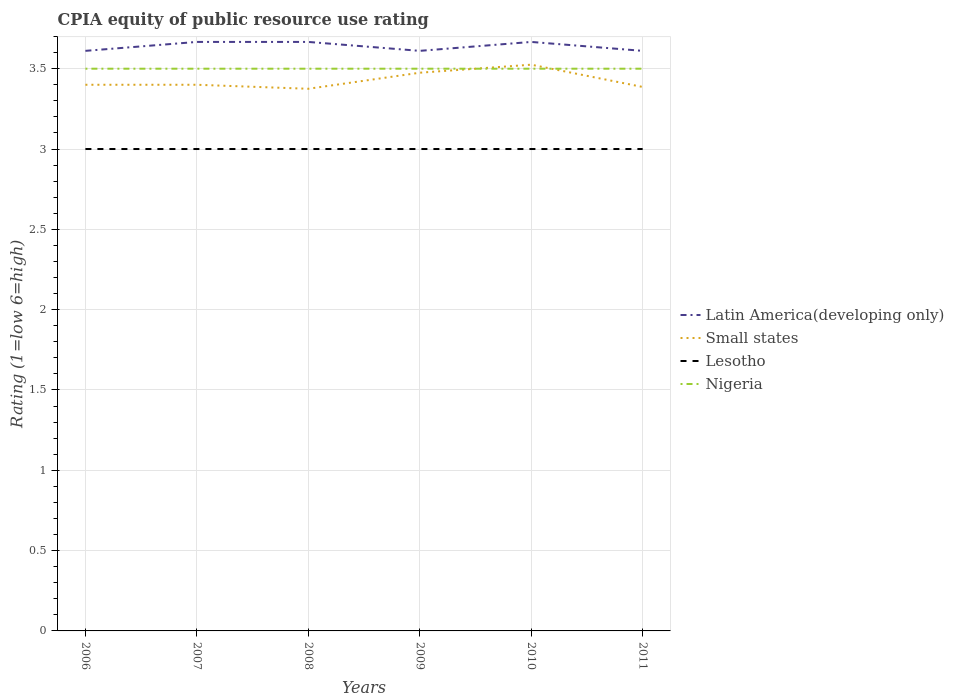Across all years, what is the maximum CPIA rating in Small states?
Provide a short and direct response. 3.38. What is the total CPIA rating in Small states in the graph?
Keep it short and to the point. 0.01. What is the difference between the highest and the second highest CPIA rating in Latin America(developing only)?
Make the answer very short. 0.06. Is the CPIA rating in Nigeria strictly greater than the CPIA rating in Lesotho over the years?
Ensure brevity in your answer.  No. Are the values on the major ticks of Y-axis written in scientific E-notation?
Offer a terse response. No. Does the graph contain grids?
Give a very brief answer. Yes. Where does the legend appear in the graph?
Keep it short and to the point. Center right. How are the legend labels stacked?
Your answer should be compact. Vertical. What is the title of the graph?
Give a very brief answer. CPIA equity of public resource use rating. Does "Jamaica" appear as one of the legend labels in the graph?
Offer a very short reply. No. What is the Rating (1=low 6=high) of Latin America(developing only) in 2006?
Make the answer very short. 3.61. What is the Rating (1=low 6=high) of Small states in 2006?
Ensure brevity in your answer.  3.4. What is the Rating (1=low 6=high) of Nigeria in 2006?
Your response must be concise. 3.5. What is the Rating (1=low 6=high) in Latin America(developing only) in 2007?
Your response must be concise. 3.67. What is the Rating (1=low 6=high) of Small states in 2007?
Ensure brevity in your answer.  3.4. What is the Rating (1=low 6=high) of Latin America(developing only) in 2008?
Provide a short and direct response. 3.67. What is the Rating (1=low 6=high) of Small states in 2008?
Provide a short and direct response. 3.38. What is the Rating (1=low 6=high) in Lesotho in 2008?
Keep it short and to the point. 3. What is the Rating (1=low 6=high) of Nigeria in 2008?
Provide a short and direct response. 3.5. What is the Rating (1=low 6=high) in Latin America(developing only) in 2009?
Offer a terse response. 3.61. What is the Rating (1=low 6=high) in Small states in 2009?
Provide a succinct answer. 3.48. What is the Rating (1=low 6=high) in Latin America(developing only) in 2010?
Ensure brevity in your answer.  3.67. What is the Rating (1=low 6=high) of Small states in 2010?
Ensure brevity in your answer.  3.52. What is the Rating (1=low 6=high) of Lesotho in 2010?
Provide a succinct answer. 3. What is the Rating (1=low 6=high) of Latin America(developing only) in 2011?
Give a very brief answer. 3.61. What is the Rating (1=low 6=high) in Small states in 2011?
Provide a short and direct response. 3.39. What is the Rating (1=low 6=high) in Lesotho in 2011?
Ensure brevity in your answer.  3. Across all years, what is the maximum Rating (1=low 6=high) of Latin America(developing only)?
Give a very brief answer. 3.67. Across all years, what is the maximum Rating (1=low 6=high) of Small states?
Provide a short and direct response. 3.52. Across all years, what is the maximum Rating (1=low 6=high) in Lesotho?
Make the answer very short. 3. Across all years, what is the minimum Rating (1=low 6=high) in Latin America(developing only)?
Ensure brevity in your answer.  3.61. Across all years, what is the minimum Rating (1=low 6=high) of Small states?
Your answer should be compact. 3.38. Across all years, what is the minimum Rating (1=low 6=high) of Nigeria?
Your answer should be compact. 3.5. What is the total Rating (1=low 6=high) of Latin America(developing only) in the graph?
Provide a short and direct response. 21.83. What is the total Rating (1=low 6=high) of Small states in the graph?
Ensure brevity in your answer.  20.56. What is the total Rating (1=low 6=high) of Lesotho in the graph?
Offer a terse response. 18. What is the difference between the Rating (1=low 6=high) in Latin America(developing only) in 2006 and that in 2007?
Make the answer very short. -0.06. What is the difference between the Rating (1=low 6=high) in Small states in 2006 and that in 2007?
Your answer should be compact. 0. What is the difference between the Rating (1=low 6=high) of Lesotho in 2006 and that in 2007?
Your answer should be very brief. 0. What is the difference between the Rating (1=low 6=high) of Latin America(developing only) in 2006 and that in 2008?
Offer a very short reply. -0.06. What is the difference between the Rating (1=low 6=high) of Small states in 2006 and that in 2008?
Offer a very short reply. 0.03. What is the difference between the Rating (1=low 6=high) in Latin America(developing only) in 2006 and that in 2009?
Offer a very short reply. 0. What is the difference between the Rating (1=low 6=high) in Small states in 2006 and that in 2009?
Ensure brevity in your answer.  -0.07. What is the difference between the Rating (1=low 6=high) in Nigeria in 2006 and that in 2009?
Your answer should be very brief. 0. What is the difference between the Rating (1=low 6=high) of Latin America(developing only) in 2006 and that in 2010?
Your response must be concise. -0.06. What is the difference between the Rating (1=low 6=high) in Small states in 2006 and that in 2010?
Your answer should be very brief. -0.12. What is the difference between the Rating (1=low 6=high) in Lesotho in 2006 and that in 2010?
Keep it short and to the point. 0. What is the difference between the Rating (1=low 6=high) in Nigeria in 2006 and that in 2010?
Your answer should be compact. 0. What is the difference between the Rating (1=low 6=high) of Small states in 2006 and that in 2011?
Keep it short and to the point. 0.01. What is the difference between the Rating (1=low 6=high) in Lesotho in 2006 and that in 2011?
Your answer should be compact. 0. What is the difference between the Rating (1=low 6=high) of Nigeria in 2006 and that in 2011?
Provide a succinct answer. 0. What is the difference between the Rating (1=low 6=high) of Small states in 2007 and that in 2008?
Offer a very short reply. 0.03. What is the difference between the Rating (1=low 6=high) in Latin America(developing only) in 2007 and that in 2009?
Make the answer very short. 0.06. What is the difference between the Rating (1=low 6=high) of Small states in 2007 and that in 2009?
Offer a very short reply. -0.07. What is the difference between the Rating (1=low 6=high) of Small states in 2007 and that in 2010?
Make the answer very short. -0.12. What is the difference between the Rating (1=low 6=high) of Nigeria in 2007 and that in 2010?
Provide a succinct answer. 0. What is the difference between the Rating (1=low 6=high) in Latin America(developing only) in 2007 and that in 2011?
Make the answer very short. 0.06. What is the difference between the Rating (1=low 6=high) of Small states in 2007 and that in 2011?
Your response must be concise. 0.01. What is the difference between the Rating (1=low 6=high) in Lesotho in 2007 and that in 2011?
Ensure brevity in your answer.  0. What is the difference between the Rating (1=low 6=high) of Latin America(developing only) in 2008 and that in 2009?
Make the answer very short. 0.06. What is the difference between the Rating (1=low 6=high) in Lesotho in 2008 and that in 2009?
Your answer should be compact. 0. What is the difference between the Rating (1=low 6=high) of Latin America(developing only) in 2008 and that in 2010?
Ensure brevity in your answer.  0. What is the difference between the Rating (1=low 6=high) of Small states in 2008 and that in 2010?
Ensure brevity in your answer.  -0.15. What is the difference between the Rating (1=low 6=high) in Nigeria in 2008 and that in 2010?
Give a very brief answer. 0. What is the difference between the Rating (1=low 6=high) of Latin America(developing only) in 2008 and that in 2011?
Keep it short and to the point. 0.06. What is the difference between the Rating (1=low 6=high) in Small states in 2008 and that in 2011?
Make the answer very short. -0.01. What is the difference between the Rating (1=low 6=high) of Latin America(developing only) in 2009 and that in 2010?
Your response must be concise. -0.06. What is the difference between the Rating (1=low 6=high) of Small states in 2009 and that in 2010?
Offer a terse response. -0.05. What is the difference between the Rating (1=low 6=high) of Lesotho in 2009 and that in 2010?
Give a very brief answer. 0. What is the difference between the Rating (1=low 6=high) of Latin America(developing only) in 2009 and that in 2011?
Make the answer very short. 0. What is the difference between the Rating (1=low 6=high) of Small states in 2009 and that in 2011?
Your answer should be very brief. 0.09. What is the difference between the Rating (1=low 6=high) in Nigeria in 2009 and that in 2011?
Offer a very short reply. 0. What is the difference between the Rating (1=low 6=high) in Latin America(developing only) in 2010 and that in 2011?
Provide a short and direct response. 0.06. What is the difference between the Rating (1=low 6=high) in Small states in 2010 and that in 2011?
Your answer should be compact. 0.14. What is the difference between the Rating (1=low 6=high) of Latin America(developing only) in 2006 and the Rating (1=low 6=high) of Small states in 2007?
Your answer should be very brief. 0.21. What is the difference between the Rating (1=low 6=high) in Latin America(developing only) in 2006 and the Rating (1=low 6=high) in Lesotho in 2007?
Keep it short and to the point. 0.61. What is the difference between the Rating (1=low 6=high) in Latin America(developing only) in 2006 and the Rating (1=low 6=high) in Nigeria in 2007?
Make the answer very short. 0.11. What is the difference between the Rating (1=low 6=high) of Small states in 2006 and the Rating (1=low 6=high) of Lesotho in 2007?
Offer a terse response. 0.4. What is the difference between the Rating (1=low 6=high) of Small states in 2006 and the Rating (1=low 6=high) of Nigeria in 2007?
Your answer should be compact. -0.1. What is the difference between the Rating (1=low 6=high) of Latin America(developing only) in 2006 and the Rating (1=low 6=high) of Small states in 2008?
Your answer should be compact. 0.24. What is the difference between the Rating (1=low 6=high) in Latin America(developing only) in 2006 and the Rating (1=low 6=high) in Lesotho in 2008?
Ensure brevity in your answer.  0.61. What is the difference between the Rating (1=low 6=high) of Small states in 2006 and the Rating (1=low 6=high) of Nigeria in 2008?
Ensure brevity in your answer.  -0.1. What is the difference between the Rating (1=low 6=high) of Lesotho in 2006 and the Rating (1=low 6=high) of Nigeria in 2008?
Ensure brevity in your answer.  -0.5. What is the difference between the Rating (1=low 6=high) of Latin America(developing only) in 2006 and the Rating (1=low 6=high) of Small states in 2009?
Your response must be concise. 0.14. What is the difference between the Rating (1=low 6=high) of Latin America(developing only) in 2006 and the Rating (1=low 6=high) of Lesotho in 2009?
Make the answer very short. 0.61. What is the difference between the Rating (1=low 6=high) in Latin America(developing only) in 2006 and the Rating (1=low 6=high) in Nigeria in 2009?
Give a very brief answer. 0.11. What is the difference between the Rating (1=low 6=high) in Small states in 2006 and the Rating (1=low 6=high) in Lesotho in 2009?
Give a very brief answer. 0.4. What is the difference between the Rating (1=low 6=high) of Small states in 2006 and the Rating (1=low 6=high) of Nigeria in 2009?
Give a very brief answer. -0.1. What is the difference between the Rating (1=low 6=high) in Lesotho in 2006 and the Rating (1=low 6=high) in Nigeria in 2009?
Your answer should be compact. -0.5. What is the difference between the Rating (1=low 6=high) of Latin America(developing only) in 2006 and the Rating (1=low 6=high) of Small states in 2010?
Your answer should be compact. 0.09. What is the difference between the Rating (1=low 6=high) of Latin America(developing only) in 2006 and the Rating (1=low 6=high) of Lesotho in 2010?
Your answer should be very brief. 0.61. What is the difference between the Rating (1=low 6=high) in Small states in 2006 and the Rating (1=low 6=high) in Nigeria in 2010?
Offer a terse response. -0.1. What is the difference between the Rating (1=low 6=high) of Latin America(developing only) in 2006 and the Rating (1=low 6=high) of Small states in 2011?
Offer a terse response. 0.22. What is the difference between the Rating (1=low 6=high) of Latin America(developing only) in 2006 and the Rating (1=low 6=high) of Lesotho in 2011?
Ensure brevity in your answer.  0.61. What is the difference between the Rating (1=low 6=high) in Small states in 2006 and the Rating (1=low 6=high) in Lesotho in 2011?
Offer a very short reply. 0.4. What is the difference between the Rating (1=low 6=high) of Small states in 2006 and the Rating (1=low 6=high) of Nigeria in 2011?
Ensure brevity in your answer.  -0.1. What is the difference between the Rating (1=low 6=high) in Lesotho in 2006 and the Rating (1=low 6=high) in Nigeria in 2011?
Give a very brief answer. -0.5. What is the difference between the Rating (1=low 6=high) of Latin America(developing only) in 2007 and the Rating (1=low 6=high) of Small states in 2008?
Offer a terse response. 0.29. What is the difference between the Rating (1=low 6=high) of Latin America(developing only) in 2007 and the Rating (1=low 6=high) of Lesotho in 2008?
Give a very brief answer. 0.67. What is the difference between the Rating (1=low 6=high) in Small states in 2007 and the Rating (1=low 6=high) in Lesotho in 2008?
Provide a short and direct response. 0.4. What is the difference between the Rating (1=low 6=high) in Latin America(developing only) in 2007 and the Rating (1=low 6=high) in Small states in 2009?
Provide a succinct answer. 0.19. What is the difference between the Rating (1=low 6=high) of Latin America(developing only) in 2007 and the Rating (1=low 6=high) of Lesotho in 2009?
Keep it short and to the point. 0.67. What is the difference between the Rating (1=low 6=high) in Latin America(developing only) in 2007 and the Rating (1=low 6=high) in Nigeria in 2009?
Ensure brevity in your answer.  0.17. What is the difference between the Rating (1=low 6=high) of Small states in 2007 and the Rating (1=low 6=high) of Lesotho in 2009?
Give a very brief answer. 0.4. What is the difference between the Rating (1=low 6=high) in Small states in 2007 and the Rating (1=low 6=high) in Nigeria in 2009?
Ensure brevity in your answer.  -0.1. What is the difference between the Rating (1=low 6=high) of Lesotho in 2007 and the Rating (1=low 6=high) of Nigeria in 2009?
Keep it short and to the point. -0.5. What is the difference between the Rating (1=low 6=high) in Latin America(developing only) in 2007 and the Rating (1=low 6=high) in Small states in 2010?
Your response must be concise. 0.14. What is the difference between the Rating (1=low 6=high) of Latin America(developing only) in 2007 and the Rating (1=low 6=high) of Lesotho in 2010?
Ensure brevity in your answer.  0.67. What is the difference between the Rating (1=low 6=high) of Latin America(developing only) in 2007 and the Rating (1=low 6=high) of Nigeria in 2010?
Your answer should be very brief. 0.17. What is the difference between the Rating (1=low 6=high) of Small states in 2007 and the Rating (1=low 6=high) of Nigeria in 2010?
Give a very brief answer. -0.1. What is the difference between the Rating (1=low 6=high) in Latin America(developing only) in 2007 and the Rating (1=low 6=high) in Small states in 2011?
Give a very brief answer. 0.28. What is the difference between the Rating (1=low 6=high) in Latin America(developing only) in 2007 and the Rating (1=low 6=high) in Nigeria in 2011?
Offer a terse response. 0.17. What is the difference between the Rating (1=low 6=high) in Lesotho in 2007 and the Rating (1=low 6=high) in Nigeria in 2011?
Offer a terse response. -0.5. What is the difference between the Rating (1=low 6=high) of Latin America(developing only) in 2008 and the Rating (1=low 6=high) of Small states in 2009?
Make the answer very short. 0.19. What is the difference between the Rating (1=low 6=high) of Latin America(developing only) in 2008 and the Rating (1=low 6=high) of Lesotho in 2009?
Offer a terse response. 0.67. What is the difference between the Rating (1=low 6=high) of Small states in 2008 and the Rating (1=low 6=high) of Nigeria in 2009?
Offer a very short reply. -0.12. What is the difference between the Rating (1=low 6=high) in Lesotho in 2008 and the Rating (1=low 6=high) in Nigeria in 2009?
Make the answer very short. -0.5. What is the difference between the Rating (1=low 6=high) of Latin America(developing only) in 2008 and the Rating (1=low 6=high) of Small states in 2010?
Provide a succinct answer. 0.14. What is the difference between the Rating (1=low 6=high) of Small states in 2008 and the Rating (1=low 6=high) of Nigeria in 2010?
Your answer should be very brief. -0.12. What is the difference between the Rating (1=low 6=high) of Latin America(developing only) in 2008 and the Rating (1=low 6=high) of Small states in 2011?
Your answer should be very brief. 0.28. What is the difference between the Rating (1=low 6=high) in Latin America(developing only) in 2008 and the Rating (1=low 6=high) in Lesotho in 2011?
Your response must be concise. 0.67. What is the difference between the Rating (1=low 6=high) of Latin America(developing only) in 2008 and the Rating (1=low 6=high) of Nigeria in 2011?
Keep it short and to the point. 0.17. What is the difference between the Rating (1=low 6=high) in Small states in 2008 and the Rating (1=low 6=high) in Lesotho in 2011?
Offer a very short reply. 0.38. What is the difference between the Rating (1=low 6=high) of Small states in 2008 and the Rating (1=low 6=high) of Nigeria in 2011?
Your answer should be compact. -0.12. What is the difference between the Rating (1=low 6=high) of Lesotho in 2008 and the Rating (1=low 6=high) of Nigeria in 2011?
Offer a terse response. -0.5. What is the difference between the Rating (1=low 6=high) in Latin America(developing only) in 2009 and the Rating (1=low 6=high) in Small states in 2010?
Provide a succinct answer. 0.09. What is the difference between the Rating (1=low 6=high) of Latin America(developing only) in 2009 and the Rating (1=low 6=high) of Lesotho in 2010?
Offer a terse response. 0.61. What is the difference between the Rating (1=low 6=high) in Small states in 2009 and the Rating (1=low 6=high) in Lesotho in 2010?
Keep it short and to the point. 0.47. What is the difference between the Rating (1=low 6=high) in Small states in 2009 and the Rating (1=low 6=high) in Nigeria in 2010?
Your answer should be very brief. -0.03. What is the difference between the Rating (1=low 6=high) in Latin America(developing only) in 2009 and the Rating (1=low 6=high) in Small states in 2011?
Make the answer very short. 0.22. What is the difference between the Rating (1=low 6=high) in Latin America(developing only) in 2009 and the Rating (1=low 6=high) in Lesotho in 2011?
Provide a short and direct response. 0.61. What is the difference between the Rating (1=low 6=high) of Latin America(developing only) in 2009 and the Rating (1=low 6=high) of Nigeria in 2011?
Offer a very short reply. 0.11. What is the difference between the Rating (1=low 6=high) of Small states in 2009 and the Rating (1=low 6=high) of Lesotho in 2011?
Make the answer very short. 0.47. What is the difference between the Rating (1=low 6=high) of Small states in 2009 and the Rating (1=low 6=high) of Nigeria in 2011?
Ensure brevity in your answer.  -0.03. What is the difference between the Rating (1=low 6=high) of Lesotho in 2009 and the Rating (1=low 6=high) of Nigeria in 2011?
Ensure brevity in your answer.  -0.5. What is the difference between the Rating (1=low 6=high) in Latin America(developing only) in 2010 and the Rating (1=low 6=high) in Small states in 2011?
Make the answer very short. 0.28. What is the difference between the Rating (1=low 6=high) of Latin America(developing only) in 2010 and the Rating (1=low 6=high) of Lesotho in 2011?
Keep it short and to the point. 0.67. What is the difference between the Rating (1=low 6=high) in Small states in 2010 and the Rating (1=low 6=high) in Lesotho in 2011?
Your answer should be compact. 0.53. What is the difference between the Rating (1=low 6=high) in Small states in 2010 and the Rating (1=low 6=high) in Nigeria in 2011?
Give a very brief answer. 0.03. What is the difference between the Rating (1=low 6=high) of Lesotho in 2010 and the Rating (1=low 6=high) of Nigeria in 2011?
Provide a succinct answer. -0.5. What is the average Rating (1=low 6=high) of Latin America(developing only) per year?
Provide a short and direct response. 3.64. What is the average Rating (1=low 6=high) of Small states per year?
Your answer should be compact. 3.43. What is the average Rating (1=low 6=high) of Lesotho per year?
Offer a very short reply. 3. What is the average Rating (1=low 6=high) of Nigeria per year?
Provide a succinct answer. 3.5. In the year 2006, what is the difference between the Rating (1=low 6=high) of Latin America(developing only) and Rating (1=low 6=high) of Small states?
Provide a short and direct response. 0.21. In the year 2006, what is the difference between the Rating (1=low 6=high) of Latin America(developing only) and Rating (1=low 6=high) of Lesotho?
Make the answer very short. 0.61. In the year 2006, what is the difference between the Rating (1=low 6=high) in Latin America(developing only) and Rating (1=low 6=high) in Nigeria?
Your answer should be very brief. 0.11. In the year 2006, what is the difference between the Rating (1=low 6=high) in Small states and Rating (1=low 6=high) in Nigeria?
Your answer should be very brief. -0.1. In the year 2007, what is the difference between the Rating (1=low 6=high) in Latin America(developing only) and Rating (1=low 6=high) in Small states?
Offer a terse response. 0.27. In the year 2007, what is the difference between the Rating (1=low 6=high) in Latin America(developing only) and Rating (1=low 6=high) in Nigeria?
Offer a very short reply. 0.17. In the year 2007, what is the difference between the Rating (1=low 6=high) in Small states and Rating (1=low 6=high) in Lesotho?
Provide a short and direct response. 0.4. In the year 2008, what is the difference between the Rating (1=low 6=high) in Latin America(developing only) and Rating (1=low 6=high) in Small states?
Make the answer very short. 0.29. In the year 2008, what is the difference between the Rating (1=low 6=high) in Latin America(developing only) and Rating (1=low 6=high) in Nigeria?
Your answer should be very brief. 0.17. In the year 2008, what is the difference between the Rating (1=low 6=high) in Small states and Rating (1=low 6=high) in Lesotho?
Your response must be concise. 0.38. In the year 2008, what is the difference between the Rating (1=low 6=high) in Small states and Rating (1=low 6=high) in Nigeria?
Your answer should be very brief. -0.12. In the year 2009, what is the difference between the Rating (1=low 6=high) of Latin America(developing only) and Rating (1=low 6=high) of Small states?
Your answer should be compact. 0.14. In the year 2009, what is the difference between the Rating (1=low 6=high) in Latin America(developing only) and Rating (1=low 6=high) in Lesotho?
Your answer should be very brief. 0.61. In the year 2009, what is the difference between the Rating (1=low 6=high) of Small states and Rating (1=low 6=high) of Lesotho?
Offer a terse response. 0.47. In the year 2009, what is the difference between the Rating (1=low 6=high) of Small states and Rating (1=low 6=high) of Nigeria?
Give a very brief answer. -0.03. In the year 2009, what is the difference between the Rating (1=low 6=high) of Lesotho and Rating (1=low 6=high) of Nigeria?
Keep it short and to the point. -0.5. In the year 2010, what is the difference between the Rating (1=low 6=high) in Latin America(developing only) and Rating (1=low 6=high) in Small states?
Provide a succinct answer. 0.14. In the year 2010, what is the difference between the Rating (1=low 6=high) in Latin America(developing only) and Rating (1=low 6=high) in Lesotho?
Keep it short and to the point. 0.67. In the year 2010, what is the difference between the Rating (1=low 6=high) in Latin America(developing only) and Rating (1=low 6=high) in Nigeria?
Keep it short and to the point. 0.17. In the year 2010, what is the difference between the Rating (1=low 6=high) of Small states and Rating (1=low 6=high) of Lesotho?
Your answer should be compact. 0.53. In the year 2010, what is the difference between the Rating (1=low 6=high) of Small states and Rating (1=low 6=high) of Nigeria?
Your response must be concise. 0.03. In the year 2010, what is the difference between the Rating (1=low 6=high) of Lesotho and Rating (1=low 6=high) of Nigeria?
Your answer should be very brief. -0.5. In the year 2011, what is the difference between the Rating (1=low 6=high) of Latin America(developing only) and Rating (1=low 6=high) of Small states?
Your answer should be compact. 0.22. In the year 2011, what is the difference between the Rating (1=low 6=high) of Latin America(developing only) and Rating (1=low 6=high) of Lesotho?
Offer a terse response. 0.61. In the year 2011, what is the difference between the Rating (1=low 6=high) of Small states and Rating (1=low 6=high) of Lesotho?
Your answer should be very brief. 0.39. In the year 2011, what is the difference between the Rating (1=low 6=high) in Small states and Rating (1=low 6=high) in Nigeria?
Offer a very short reply. -0.11. In the year 2011, what is the difference between the Rating (1=low 6=high) of Lesotho and Rating (1=low 6=high) of Nigeria?
Offer a very short reply. -0.5. What is the ratio of the Rating (1=low 6=high) in Latin America(developing only) in 2006 to that in 2007?
Ensure brevity in your answer.  0.98. What is the ratio of the Rating (1=low 6=high) in Small states in 2006 to that in 2007?
Your response must be concise. 1. What is the ratio of the Rating (1=low 6=high) in Nigeria in 2006 to that in 2007?
Your answer should be very brief. 1. What is the ratio of the Rating (1=low 6=high) in Small states in 2006 to that in 2008?
Offer a terse response. 1.01. What is the ratio of the Rating (1=low 6=high) in Nigeria in 2006 to that in 2008?
Keep it short and to the point. 1. What is the ratio of the Rating (1=low 6=high) of Latin America(developing only) in 2006 to that in 2009?
Keep it short and to the point. 1. What is the ratio of the Rating (1=low 6=high) of Small states in 2006 to that in 2009?
Your response must be concise. 0.98. What is the ratio of the Rating (1=low 6=high) of Lesotho in 2006 to that in 2009?
Make the answer very short. 1. What is the ratio of the Rating (1=low 6=high) of Nigeria in 2006 to that in 2009?
Keep it short and to the point. 1. What is the ratio of the Rating (1=low 6=high) in Latin America(developing only) in 2006 to that in 2010?
Your answer should be very brief. 0.98. What is the ratio of the Rating (1=low 6=high) in Small states in 2006 to that in 2010?
Offer a terse response. 0.96. What is the ratio of the Rating (1=low 6=high) of Lesotho in 2006 to that in 2010?
Offer a terse response. 1. What is the ratio of the Rating (1=low 6=high) of Nigeria in 2006 to that in 2010?
Make the answer very short. 1. What is the ratio of the Rating (1=low 6=high) in Latin America(developing only) in 2006 to that in 2011?
Ensure brevity in your answer.  1. What is the ratio of the Rating (1=low 6=high) of Small states in 2006 to that in 2011?
Provide a succinct answer. 1. What is the ratio of the Rating (1=low 6=high) in Nigeria in 2006 to that in 2011?
Offer a very short reply. 1. What is the ratio of the Rating (1=low 6=high) of Small states in 2007 to that in 2008?
Ensure brevity in your answer.  1.01. What is the ratio of the Rating (1=low 6=high) of Lesotho in 2007 to that in 2008?
Keep it short and to the point. 1. What is the ratio of the Rating (1=low 6=high) of Latin America(developing only) in 2007 to that in 2009?
Offer a very short reply. 1.02. What is the ratio of the Rating (1=low 6=high) of Small states in 2007 to that in 2009?
Give a very brief answer. 0.98. What is the ratio of the Rating (1=low 6=high) of Lesotho in 2007 to that in 2009?
Provide a short and direct response. 1. What is the ratio of the Rating (1=low 6=high) in Nigeria in 2007 to that in 2009?
Your response must be concise. 1. What is the ratio of the Rating (1=low 6=high) of Small states in 2007 to that in 2010?
Your response must be concise. 0.96. What is the ratio of the Rating (1=low 6=high) of Lesotho in 2007 to that in 2010?
Give a very brief answer. 1. What is the ratio of the Rating (1=low 6=high) in Latin America(developing only) in 2007 to that in 2011?
Your response must be concise. 1.02. What is the ratio of the Rating (1=low 6=high) in Small states in 2007 to that in 2011?
Give a very brief answer. 1. What is the ratio of the Rating (1=low 6=high) of Lesotho in 2007 to that in 2011?
Make the answer very short. 1. What is the ratio of the Rating (1=low 6=high) in Nigeria in 2007 to that in 2011?
Make the answer very short. 1. What is the ratio of the Rating (1=low 6=high) in Latin America(developing only) in 2008 to that in 2009?
Keep it short and to the point. 1.02. What is the ratio of the Rating (1=low 6=high) in Small states in 2008 to that in 2009?
Offer a terse response. 0.97. What is the ratio of the Rating (1=low 6=high) in Nigeria in 2008 to that in 2009?
Offer a terse response. 1. What is the ratio of the Rating (1=low 6=high) of Latin America(developing only) in 2008 to that in 2010?
Your answer should be compact. 1. What is the ratio of the Rating (1=low 6=high) in Small states in 2008 to that in 2010?
Offer a very short reply. 0.96. What is the ratio of the Rating (1=low 6=high) of Latin America(developing only) in 2008 to that in 2011?
Offer a terse response. 1.02. What is the ratio of the Rating (1=low 6=high) in Lesotho in 2008 to that in 2011?
Your answer should be very brief. 1. What is the ratio of the Rating (1=low 6=high) of Latin America(developing only) in 2009 to that in 2010?
Give a very brief answer. 0.98. What is the ratio of the Rating (1=low 6=high) in Small states in 2009 to that in 2010?
Ensure brevity in your answer.  0.99. What is the ratio of the Rating (1=low 6=high) in Latin America(developing only) in 2009 to that in 2011?
Your response must be concise. 1. What is the ratio of the Rating (1=low 6=high) in Small states in 2009 to that in 2011?
Give a very brief answer. 1.03. What is the ratio of the Rating (1=low 6=high) in Lesotho in 2009 to that in 2011?
Ensure brevity in your answer.  1. What is the ratio of the Rating (1=low 6=high) of Nigeria in 2009 to that in 2011?
Provide a succinct answer. 1. What is the ratio of the Rating (1=low 6=high) in Latin America(developing only) in 2010 to that in 2011?
Your response must be concise. 1.02. What is the ratio of the Rating (1=low 6=high) of Small states in 2010 to that in 2011?
Provide a succinct answer. 1.04. What is the ratio of the Rating (1=low 6=high) of Lesotho in 2010 to that in 2011?
Provide a short and direct response. 1. What is the difference between the highest and the second highest Rating (1=low 6=high) of Latin America(developing only)?
Ensure brevity in your answer.  0. What is the difference between the highest and the second highest Rating (1=low 6=high) in Nigeria?
Provide a short and direct response. 0. What is the difference between the highest and the lowest Rating (1=low 6=high) of Latin America(developing only)?
Your response must be concise. 0.06. 